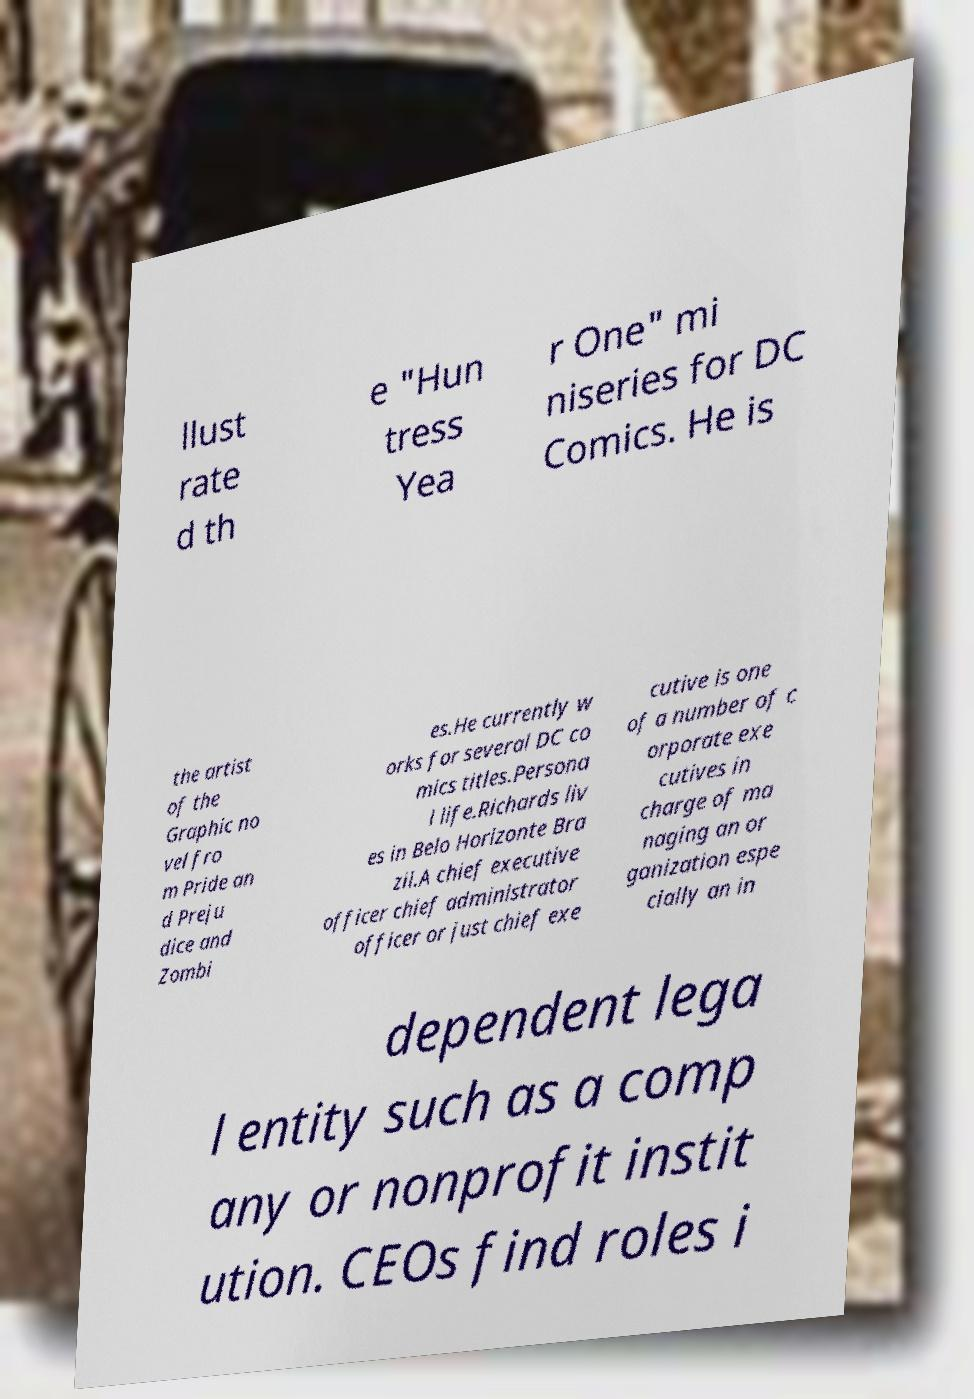Please identify and transcribe the text found in this image. llust rate d th e "Hun tress Yea r One" mi niseries for DC Comics. He is the artist of the Graphic no vel fro m Pride an d Preju dice and Zombi es.He currently w orks for several DC co mics titles.Persona l life.Richards liv es in Belo Horizonte Bra zil.A chief executive officer chief administrator officer or just chief exe cutive is one of a number of c orporate exe cutives in charge of ma naging an or ganization espe cially an in dependent lega l entity such as a comp any or nonprofit instit ution. CEOs find roles i 